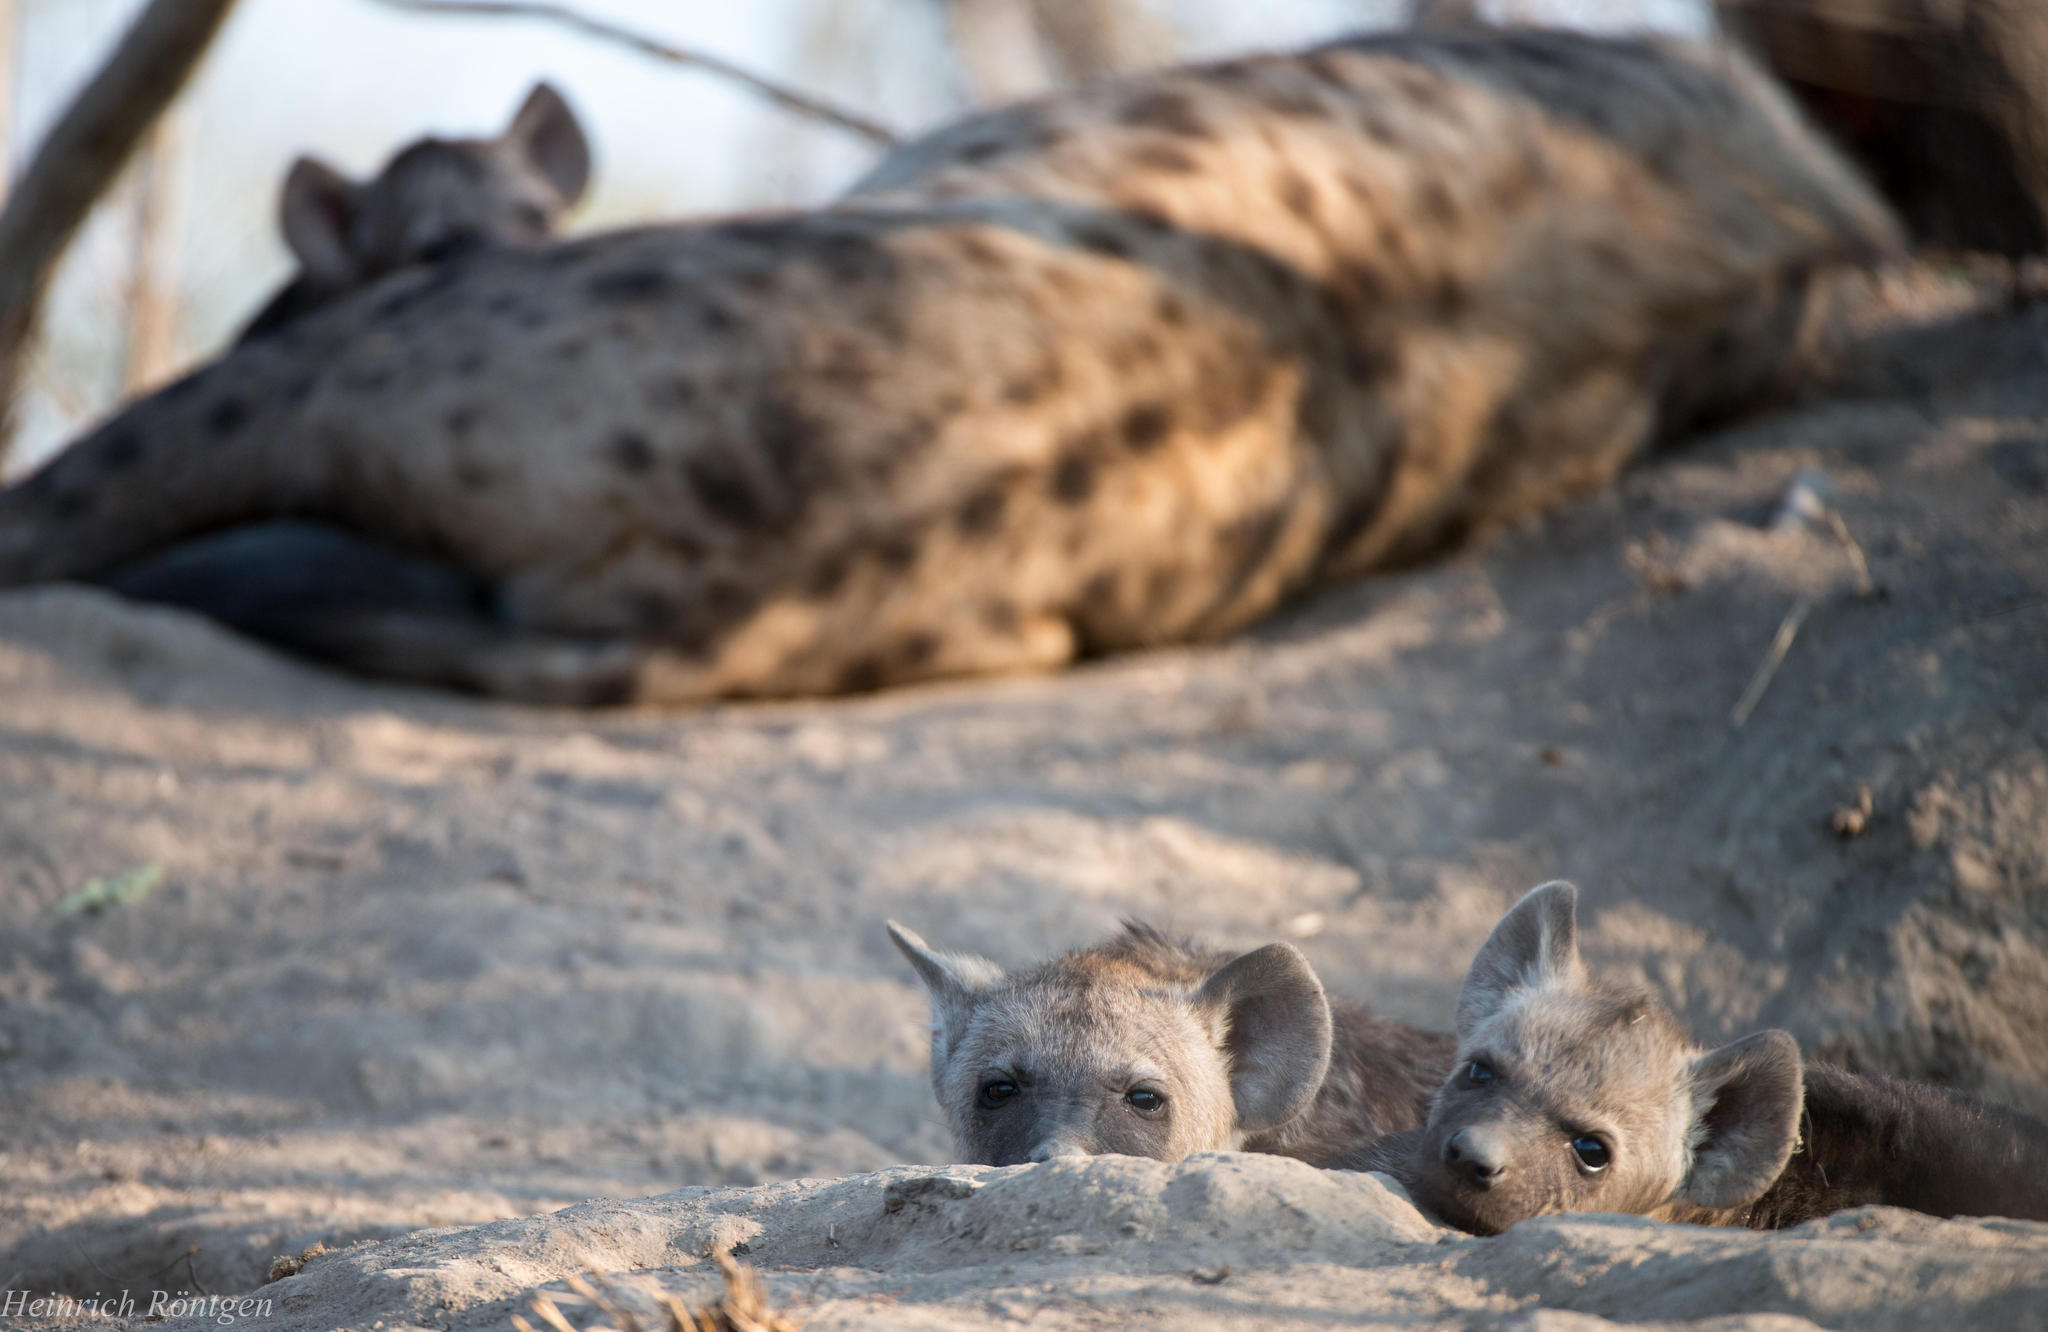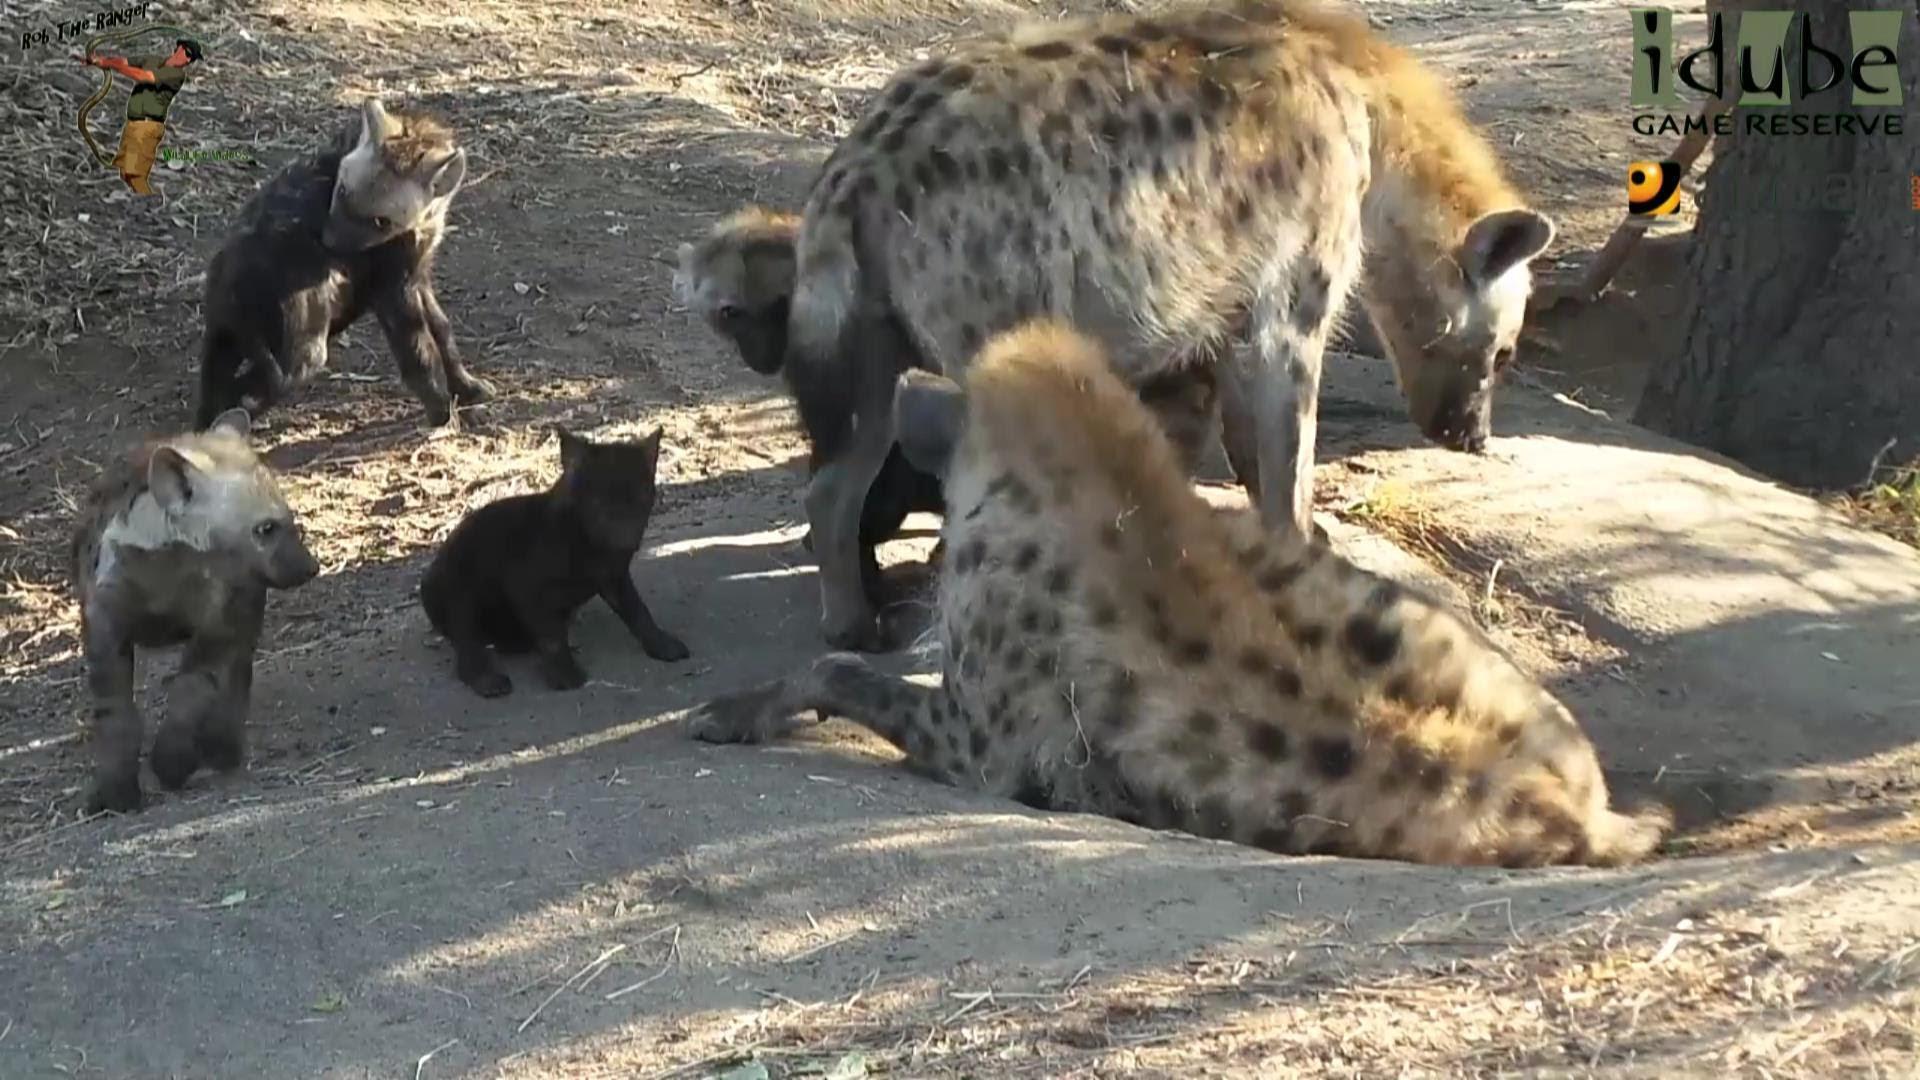The first image is the image on the left, the second image is the image on the right. Given the left and right images, does the statement "There are some lion cubs here." hold true? Answer yes or no. No. 